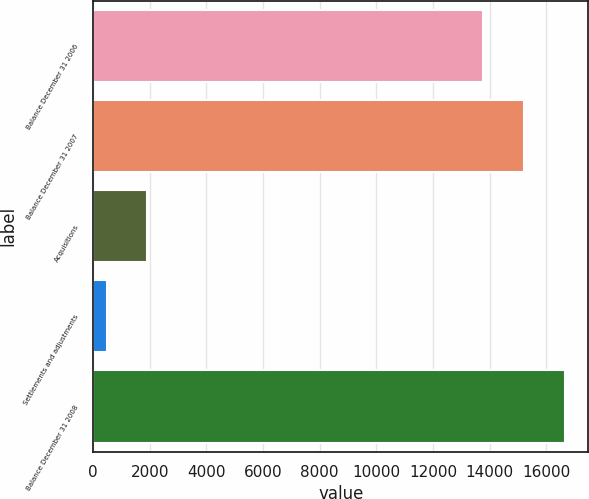Convert chart. <chart><loc_0><loc_0><loc_500><loc_500><bar_chart><fcel>Balance December 31 2006<fcel>Balance December 31 2007<fcel>Acquisitions<fcel>Settlements and adjustments<fcel>Balance December 31 2008<nl><fcel>13768<fcel>15209.9<fcel>1911.9<fcel>470<fcel>16651.8<nl></chart> 